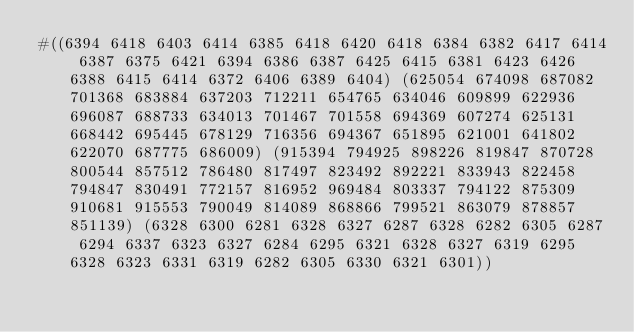Convert code to text. <code><loc_0><loc_0><loc_500><loc_500><_Racket_>#((6394 6418 6403 6414 6385 6418 6420 6418 6384 6382 6417 6414 6387 6375 6421 6394 6386 6387 6425 6415 6381 6423 6426 6388 6415 6414 6372 6406 6389 6404) (625054 674098 687082 701368 683884 637203 712211 654765 634046 609899 622936 696087 688733 634013 701467 701558 694369 607274 625131 668442 695445 678129 716356 694367 651895 621001 641802 622070 687775 686009) (915394 794925 898226 819847 870728 800544 857512 786480 817497 823492 892221 833943 822458 794847 830491 772157 816952 969484 803337 794122 875309 910681 915553 790049 814089 868866 799521 863079 878857 851139) (6328 6300 6281 6328 6327 6287 6328 6282 6305 6287 6294 6337 6323 6327 6284 6295 6321 6328 6327 6319 6295 6328 6323 6331 6319 6282 6305 6330 6321 6301))</code> 